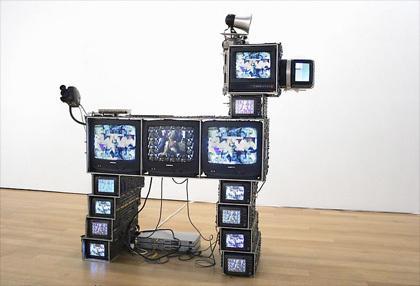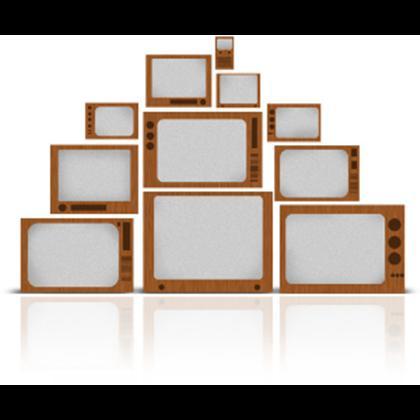The first image is the image on the left, the second image is the image on the right. Considering the images on both sides, is "In one image, the monitors are stacked in the shape of an animal or person." valid? Answer yes or no. Yes. The first image is the image on the left, the second image is the image on the right. Given the left and right images, does the statement "Tv's are stacked on a wood floor with a white wall" hold true? Answer yes or no. Yes. 